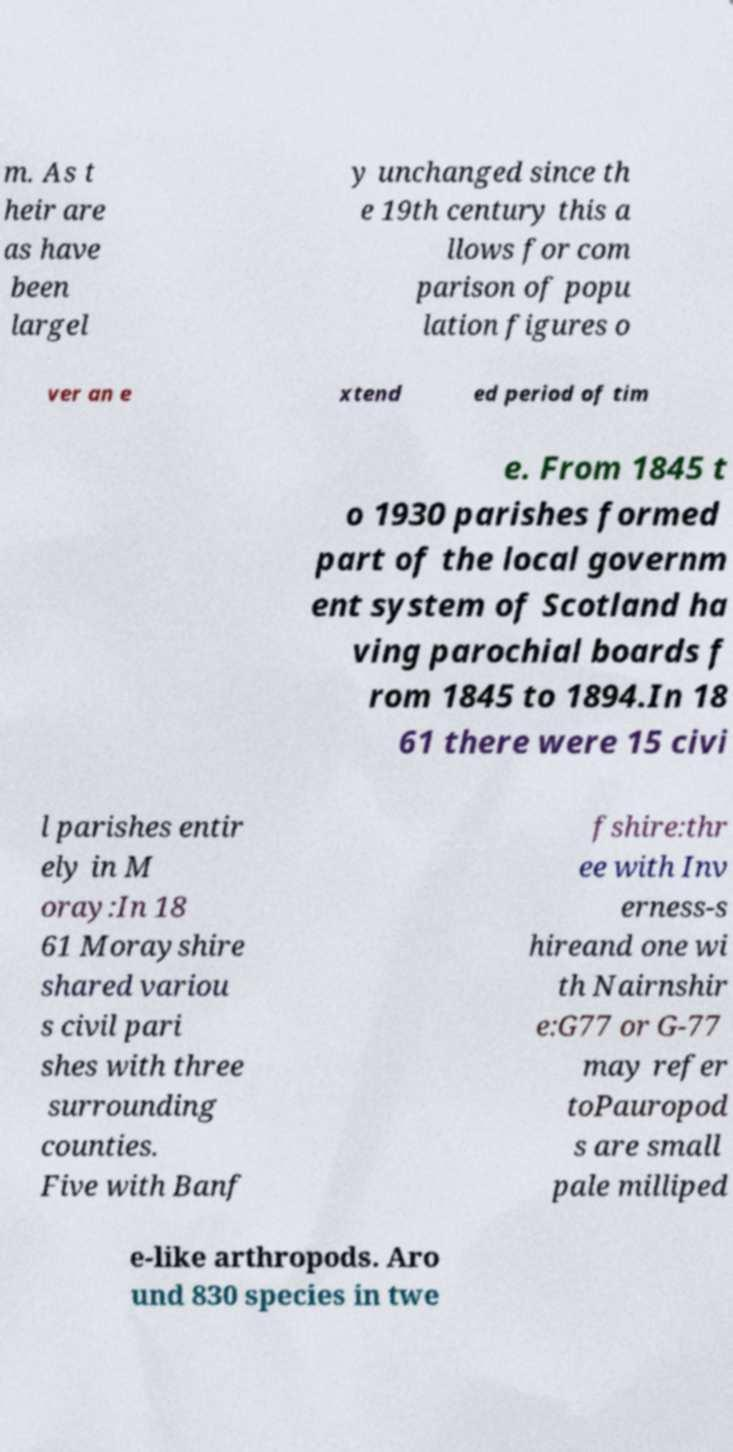Please identify and transcribe the text found in this image. m. As t heir are as have been largel y unchanged since th e 19th century this a llows for com parison of popu lation figures o ver an e xtend ed period of tim e. From 1845 t o 1930 parishes formed part of the local governm ent system of Scotland ha ving parochial boards f rom 1845 to 1894.In 18 61 there were 15 civi l parishes entir ely in M oray:In 18 61 Morayshire shared variou s civil pari shes with three surrounding counties. Five with Banf fshire:thr ee with Inv erness-s hireand one wi th Nairnshir e:G77 or G-77 may refer toPauropod s are small pale milliped e-like arthropods. Aro und 830 species in twe 